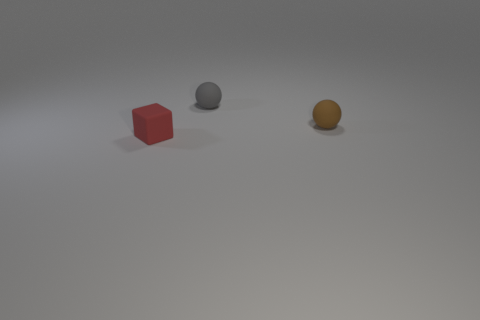Subtract all brown spheres. How many spheres are left? 1 Add 1 big cyan matte cylinders. How many objects exist? 4 Subtract all blocks. How many objects are left? 2 Add 3 small gray balls. How many small gray balls exist? 4 Subtract 0 green spheres. How many objects are left? 3 Subtract 1 balls. How many balls are left? 1 Subtract all blue blocks. Subtract all brown spheres. How many blocks are left? 1 Subtract all blue cylinders. How many brown spheres are left? 1 Subtract all small purple things. Subtract all tiny brown objects. How many objects are left? 2 Add 2 rubber things. How many rubber things are left? 5 